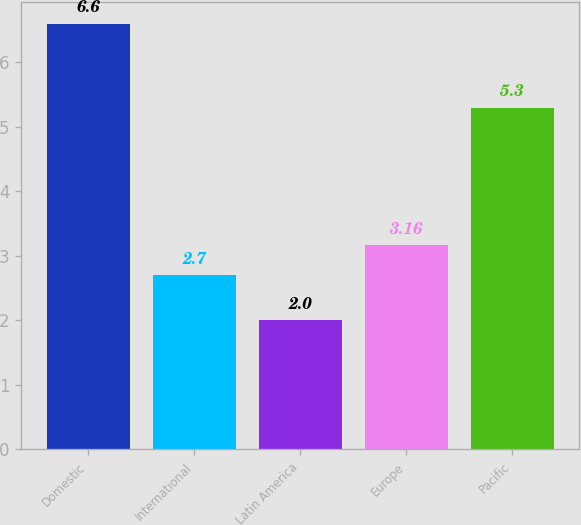Convert chart. <chart><loc_0><loc_0><loc_500><loc_500><bar_chart><fcel>Domestic<fcel>International<fcel>Latin America<fcel>Europe<fcel>Pacific<nl><fcel>6.6<fcel>2.7<fcel>2<fcel>3.16<fcel>5.3<nl></chart> 